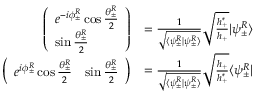<formula> <loc_0><loc_0><loc_500><loc_500>\begin{array} { r l } { \left ( \begin{array} { l } { e ^ { - i \phi _ { \pm } ^ { R } } \cos \frac { \theta _ { \pm } ^ { R } } { 2 } } \\ { \sin \frac { \theta _ { \pm } ^ { R } } { 2 } } \end{array} \right ) } & { = \frac { 1 } { \sqrt { \langle \psi _ { \pm } ^ { R } | \psi _ { \pm } ^ { R } \rangle } } \sqrt { \frac { h _ { + } ^ { * } } { h _ { + } } } | \psi _ { \pm } ^ { R } \rangle } \\ { \left ( \begin{array} { l l } { e ^ { i \phi _ { \pm } ^ { R } } \cos \frac { \theta _ { \pm } ^ { R } } { 2 } } & { \sin \frac { \theta _ { \pm } ^ { R } } { 2 } } \end{array} \right ) } & { = \frac { 1 } { \sqrt { \langle \psi _ { \pm } ^ { R } | \psi _ { \pm } ^ { R } \rangle } } \sqrt { \frac { h _ { + } } { h _ { + } ^ { * } } } \langle \psi _ { \pm } ^ { R } | } \end{array}</formula> 